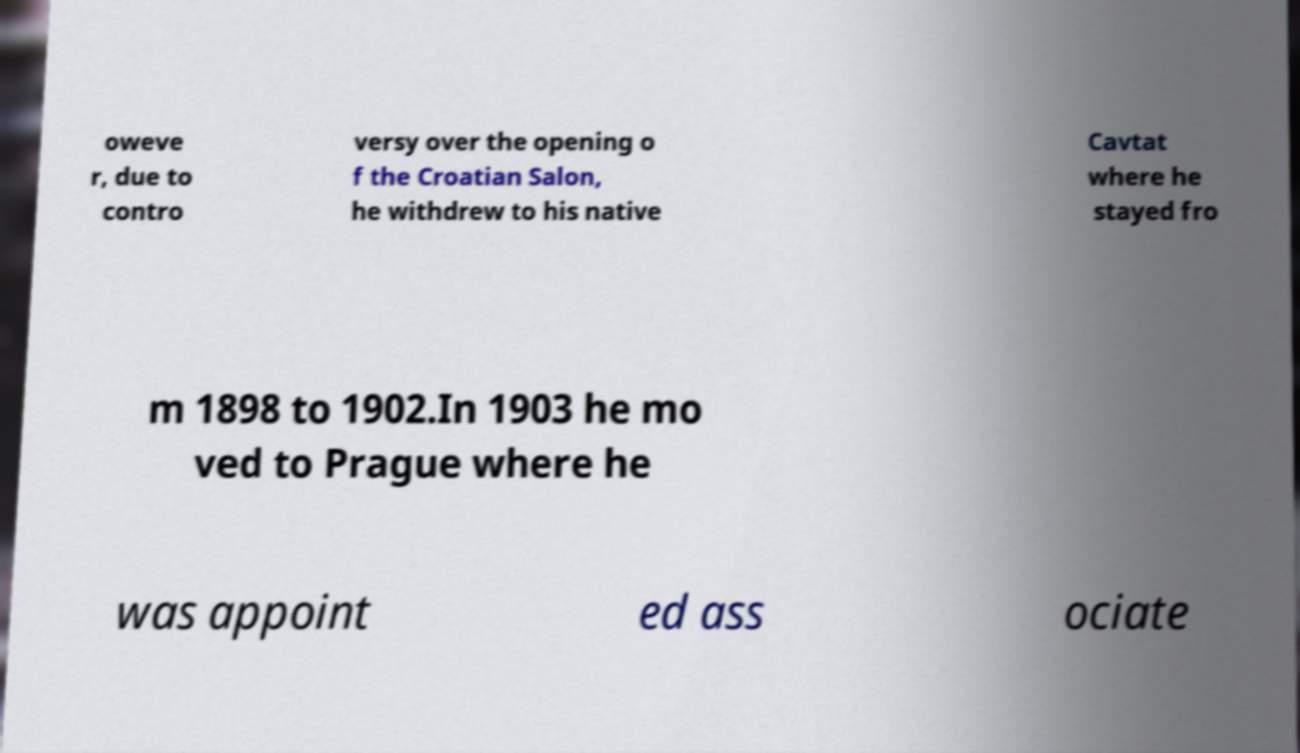Can you read and provide the text displayed in the image?This photo seems to have some interesting text. Can you extract and type it out for me? oweve r, due to contro versy over the opening o f the Croatian Salon, he withdrew to his native Cavtat where he stayed fro m 1898 to 1902.In 1903 he mo ved to Prague where he was appoint ed ass ociate 